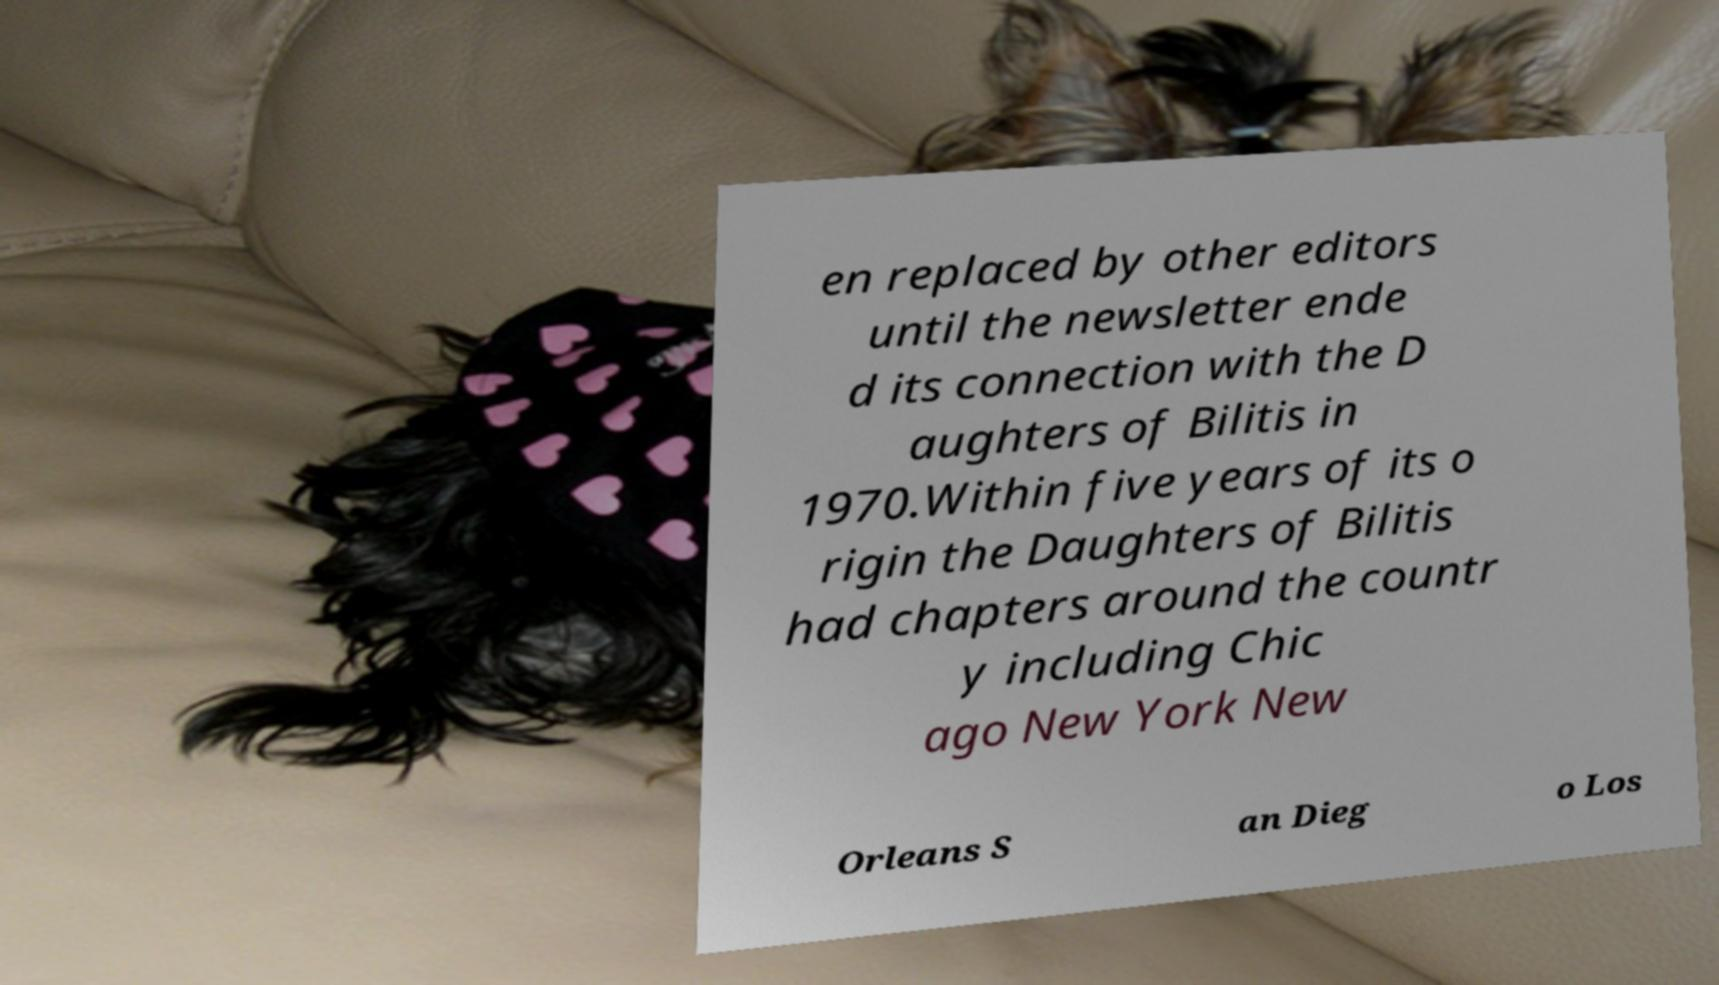Please read and relay the text visible in this image. What does it say? en replaced by other editors until the newsletter ende d its connection with the D aughters of Bilitis in 1970.Within five years of its o rigin the Daughters of Bilitis had chapters around the countr y including Chic ago New York New Orleans S an Dieg o Los 